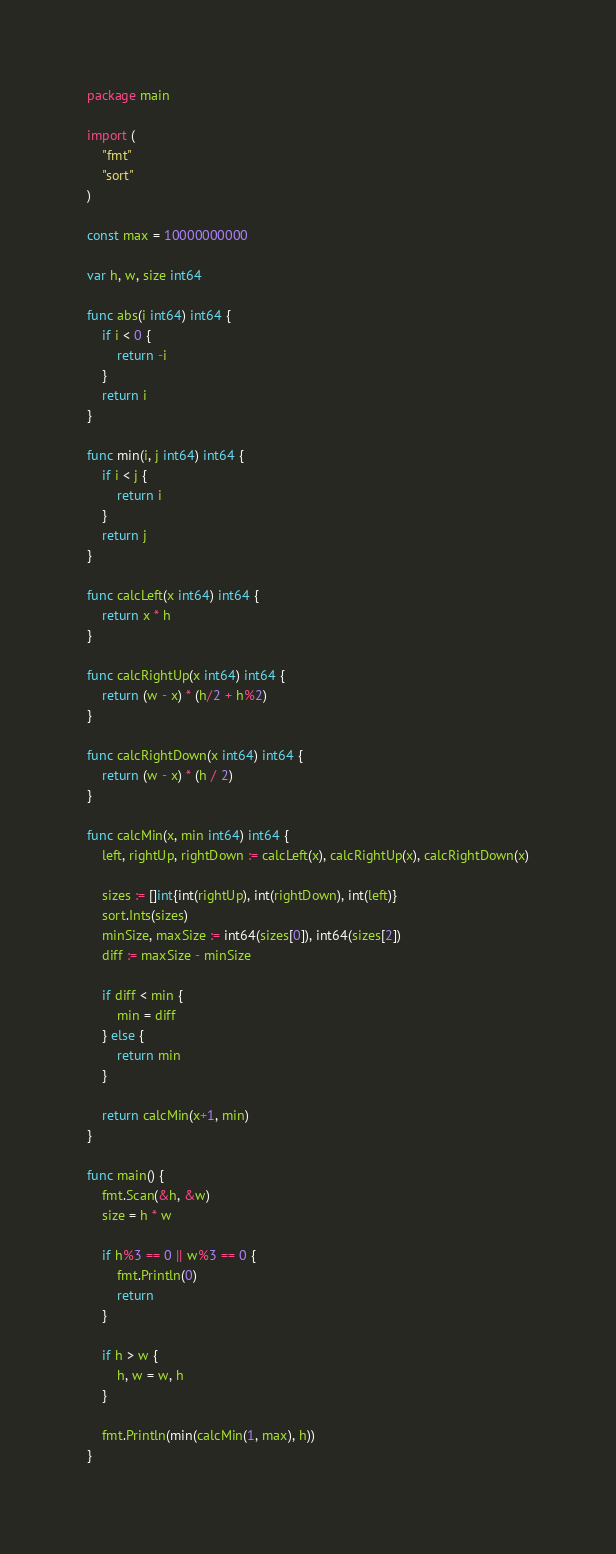Convert code to text. <code><loc_0><loc_0><loc_500><loc_500><_Go_>package main

import (
	"fmt"
	"sort"
)

const max = 10000000000

var h, w, size int64

func abs(i int64) int64 {
	if i < 0 {
		return -i
	}
	return i
}

func min(i, j int64) int64 {
	if i < j {
		return i
	}
	return j
}

func calcLeft(x int64) int64 {
	return x * h
}

func calcRightUp(x int64) int64 {
	return (w - x) * (h/2 + h%2)
}

func calcRightDown(x int64) int64 {
	return (w - x) * (h / 2)
}

func calcMin(x, min int64) int64 {
	left, rightUp, rightDown := calcLeft(x), calcRightUp(x), calcRightDown(x)

	sizes := []int{int(rightUp), int(rightDown), int(left)}
	sort.Ints(sizes)
	minSize, maxSize := int64(sizes[0]), int64(sizes[2])
	diff := maxSize - minSize

	if diff < min {
		min = diff
	} else {
		return min
	}

	return calcMin(x+1, min)
}

func main() {
	fmt.Scan(&h, &w)
	size = h * w

	if h%3 == 0 || w%3 == 0 {
		fmt.Println(0)
		return
	}

	if h > w {
		h, w = w, h
	}

	fmt.Println(min(calcMin(1, max), h))
}</code> 